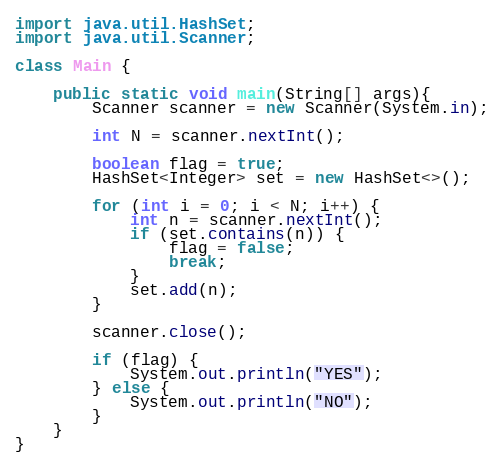Convert code to text. <code><loc_0><loc_0><loc_500><loc_500><_Java_>import java.util.HashSet;
import java.util.Scanner;

class Main {

	public static void main(String[] args){
		Scanner scanner = new Scanner(System.in);

		int N = scanner.nextInt();

		boolean flag = true;
		HashSet<Integer> set = new HashSet<>();

		for (int i = 0; i < N; i++) {
			int n = scanner.nextInt();
			if (set.contains(n)) {
				flag = false;
				break;
			}
			set.add(n);
		}
		
		scanner.close();

		if (flag) {
			System.out.println("YES");
		} else {
			System.out.println("NO");
		}	
	}
}</code> 